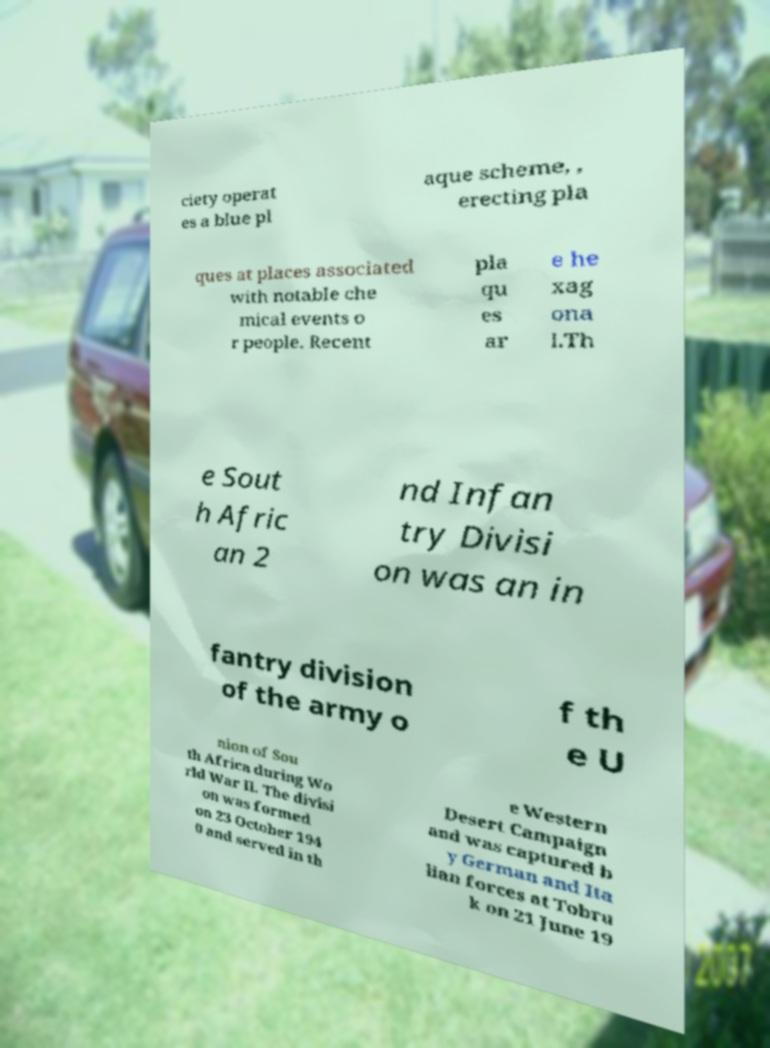Please identify and transcribe the text found in this image. ciety operat es a blue pl aque scheme, , erecting pla ques at places associated with notable che mical events o r people. Recent pla qu es ar e he xag ona l.Th e Sout h Afric an 2 nd Infan try Divisi on was an in fantry division of the army o f th e U nion of Sou th Africa during Wo rld War II. The divisi on was formed on 23 October 194 0 and served in th e Western Desert Campaign and was captured b y German and Ita lian forces at Tobru k on 21 June 19 